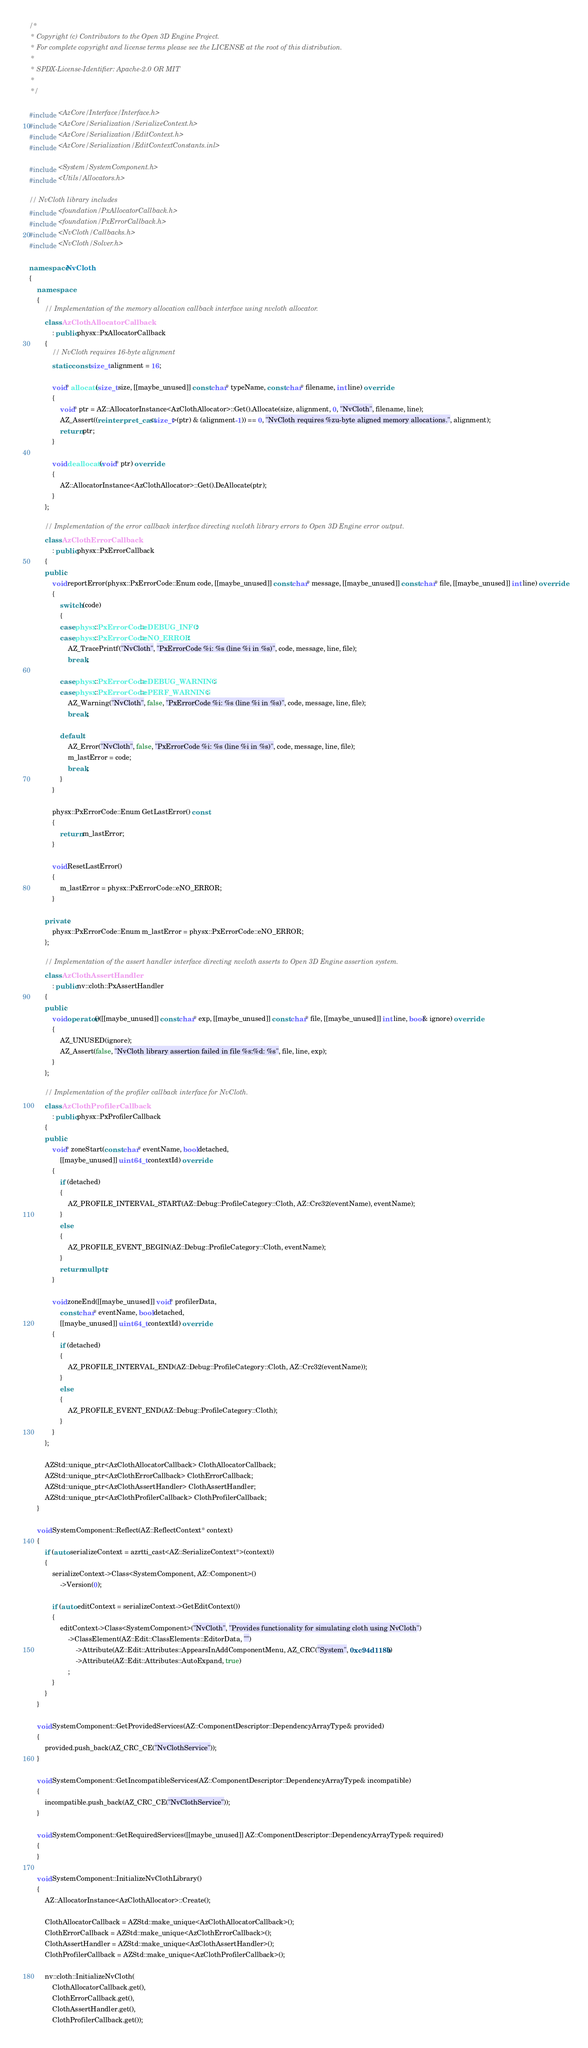Convert code to text. <code><loc_0><loc_0><loc_500><loc_500><_C++_>/*
 * Copyright (c) Contributors to the Open 3D Engine Project.
 * For complete copyright and license terms please see the LICENSE at the root of this distribution.
 *
 * SPDX-License-Identifier: Apache-2.0 OR MIT
 *
 */

#include <AzCore/Interface/Interface.h>
#include <AzCore/Serialization/SerializeContext.h>
#include <AzCore/Serialization/EditContext.h>
#include <AzCore/Serialization/EditContextConstants.inl>

#include <System/SystemComponent.h>
#include <Utils/Allocators.h>

// NvCloth library includes
#include <foundation/PxAllocatorCallback.h>
#include <foundation/PxErrorCallback.h>
#include <NvCloth/Callbacks.h>
#include <NvCloth/Solver.h>

namespace NvCloth
{
    namespace
    {
        // Implementation of the memory allocation callback interface using nvcloth allocator.
        class AzClothAllocatorCallback
            : public physx::PxAllocatorCallback
        {
            // NvCloth requires 16-byte alignment
            static const size_t alignment = 16;

            void* allocate(size_t size, [[maybe_unused]] const char* typeName, const char* filename, int line) override
            {
                void* ptr = AZ::AllocatorInstance<AzClothAllocator>::Get().Allocate(size, alignment, 0, "NvCloth", filename, line);
                AZ_Assert((reinterpret_cast<size_t>(ptr) & (alignment-1)) == 0, "NvCloth requires %zu-byte aligned memory allocations.", alignment);
                return ptr;
            }

            void deallocate(void* ptr) override
            {
                AZ::AllocatorInstance<AzClothAllocator>::Get().DeAllocate(ptr);
            }
        };

        // Implementation of the error callback interface directing nvcloth library errors to Open 3D Engine error output.
        class AzClothErrorCallback
            : public physx::PxErrorCallback
        {
        public:
            void reportError(physx::PxErrorCode::Enum code, [[maybe_unused]] const char* message, [[maybe_unused]] const char* file, [[maybe_unused]] int line) override
            {
                switch (code)
                {
                case physx::PxErrorCode::eDEBUG_INFO:
                case physx::PxErrorCode::eNO_ERROR:
                    AZ_TracePrintf("NvCloth", "PxErrorCode %i: %s (line %i in %s)", code, message, line, file);
                    break;

                case physx::PxErrorCode::eDEBUG_WARNING:
                case physx::PxErrorCode::ePERF_WARNING:
                    AZ_Warning("NvCloth", false, "PxErrorCode %i: %s (line %i in %s)", code, message, line, file);
                    break;

                default:
                    AZ_Error("NvCloth", false, "PxErrorCode %i: %s (line %i in %s)", code, message, line, file);
                    m_lastError = code;
                    break;
                }
            }

            physx::PxErrorCode::Enum GetLastError() const
            {
                return m_lastError;
            }

            void ResetLastError()
            {
                m_lastError = physx::PxErrorCode::eNO_ERROR;
            }

        private:
            physx::PxErrorCode::Enum m_lastError = physx::PxErrorCode::eNO_ERROR;
        };

        // Implementation of the assert handler interface directing nvcloth asserts to Open 3D Engine assertion system.
        class AzClothAssertHandler
            : public nv::cloth::PxAssertHandler
        {
        public:
            void operator()([[maybe_unused]] const char* exp, [[maybe_unused]] const char* file, [[maybe_unused]] int line, bool& ignore) override
            {
                AZ_UNUSED(ignore);
                AZ_Assert(false, "NvCloth library assertion failed in file %s:%d: %s", file, line, exp);
            }
        };

        // Implementation of the profiler callback interface for NvCloth.
        class AzClothProfilerCallback
            : public physx::PxProfilerCallback
        {
        public:
            void* zoneStart(const char* eventName, bool detached,
                [[maybe_unused]] uint64_t contextId) override
            {
                if (detached)
                {
                    AZ_PROFILE_INTERVAL_START(AZ::Debug::ProfileCategory::Cloth, AZ::Crc32(eventName), eventName);
                }
                else
                {
                    AZ_PROFILE_EVENT_BEGIN(AZ::Debug::ProfileCategory::Cloth, eventName);
                }
                return nullptr;
            }

            void zoneEnd([[maybe_unused]] void* profilerData,
                const char* eventName, bool detached,
                [[maybe_unused]] uint64_t contextId) override
            {
                if (detached)
                {
                    AZ_PROFILE_INTERVAL_END(AZ::Debug::ProfileCategory::Cloth, AZ::Crc32(eventName));
                }
                else
                {
                    AZ_PROFILE_EVENT_END(AZ::Debug::ProfileCategory::Cloth);
                }
            }
        };

        AZStd::unique_ptr<AzClothAllocatorCallback> ClothAllocatorCallback;
        AZStd::unique_ptr<AzClothErrorCallback> ClothErrorCallback;
        AZStd::unique_ptr<AzClothAssertHandler> ClothAssertHandler;
        AZStd::unique_ptr<AzClothProfilerCallback> ClothProfilerCallback;
    }

    void SystemComponent::Reflect(AZ::ReflectContext* context)
    {
        if (auto serializeContext = azrtti_cast<AZ::SerializeContext*>(context))
        {
            serializeContext->Class<SystemComponent, AZ::Component>()
                ->Version(0);

            if (auto editContext = serializeContext->GetEditContext())
            {
                editContext->Class<SystemComponent>("NvCloth", "Provides functionality for simulating cloth using NvCloth")
                    ->ClassElement(AZ::Edit::ClassElements::EditorData, "")
                        ->Attribute(AZ::Edit::Attributes::AppearsInAddComponentMenu, AZ_CRC("System", 0xc94d118b))
                        ->Attribute(AZ::Edit::Attributes::AutoExpand, true)
                    ;
            }
        }
    }

    void SystemComponent::GetProvidedServices(AZ::ComponentDescriptor::DependencyArrayType& provided)
    {
        provided.push_back(AZ_CRC_CE("NvClothService"));
    }

    void SystemComponent::GetIncompatibleServices(AZ::ComponentDescriptor::DependencyArrayType& incompatible)
    {
        incompatible.push_back(AZ_CRC_CE("NvClothService"));
    }

    void SystemComponent::GetRequiredServices([[maybe_unused]] AZ::ComponentDescriptor::DependencyArrayType& required)
    {
    }

    void SystemComponent::InitializeNvClothLibrary()
    {
        AZ::AllocatorInstance<AzClothAllocator>::Create();

        ClothAllocatorCallback = AZStd::make_unique<AzClothAllocatorCallback>();
        ClothErrorCallback = AZStd::make_unique<AzClothErrorCallback>();
        ClothAssertHandler = AZStd::make_unique<AzClothAssertHandler>();
        ClothProfilerCallback = AZStd::make_unique<AzClothProfilerCallback>();

        nv::cloth::InitializeNvCloth(
            ClothAllocatorCallback.get(),
            ClothErrorCallback.get(),
            ClothAssertHandler.get(),
            ClothProfilerCallback.get());</code> 